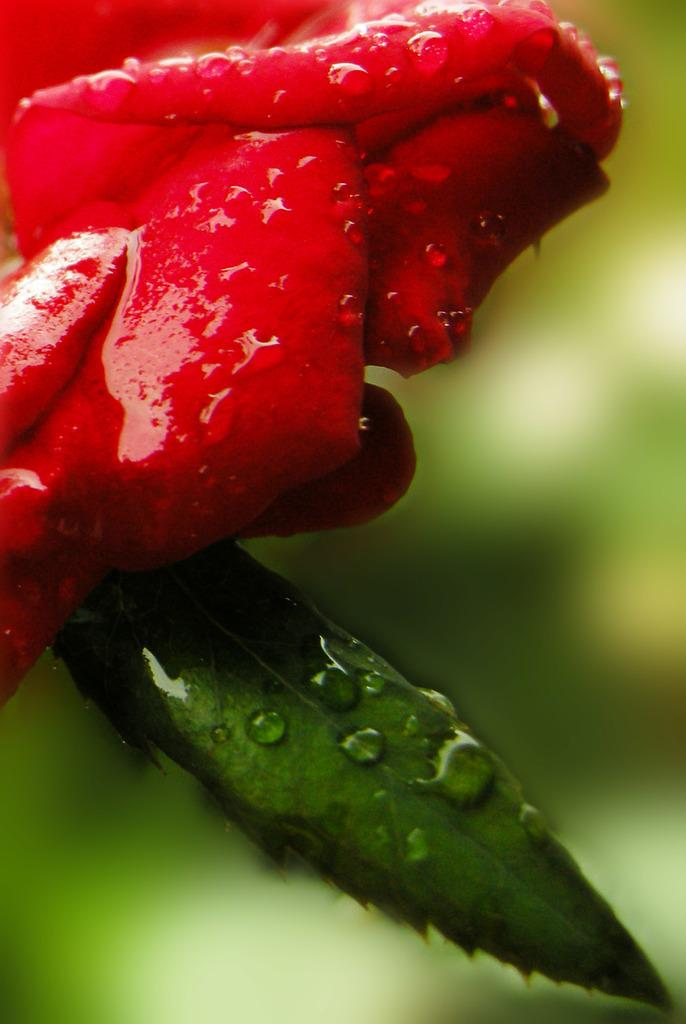What type of plant is featured in the image? There is a flower and a leaf in the picture. Are there any visible signs of moisture on the plant? Yes, there are water droplets on the flower and/or leaf. How would you describe the background of the image? The background of the image is blurry. What type of soda can be seen in the image? There is no soda present in the image; it features a flower and a leaf with water droplets. Can you describe the wave pattern on the furniture in the image? There is no furniture or wave pattern present in the image. 